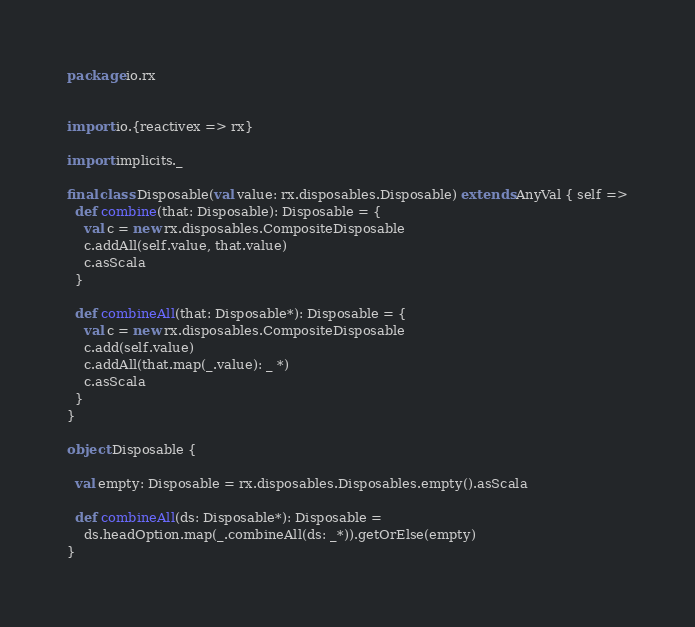Convert code to text. <code><loc_0><loc_0><loc_500><loc_500><_Scala_>package io.rx


import io.{reactivex => rx}

import implicits._

final class Disposable(val value: rx.disposables.Disposable) extends AnyVal { self =>
  def combine(that: Disposable): Disposable = {
    val c = new rx.disposables.CompositeDisposable
    c.addAll(self.value, that.value)
    c.asScala
  }

  def combineAll(that: Disposable*): Disposable = {
    val c = new rx.disposables.CompositeDisposable
    c.add(self.value)
    c.addAll(that.map(_.value): _ *)
    c.asScala
  }
}

object Disposable {

  val empty: Disposable = rx.disposables.Disposables.empty().asScala

  def combineAll(ds: Disposable*): Disposable =
    ds.headOption.map(_.combineAll(ds: _*)).getOrElse(empty)
}

</code> 